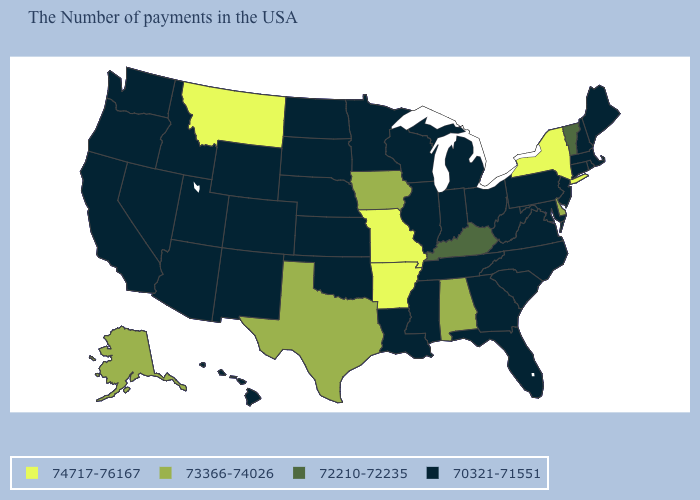What is the value of Colorado?
Be succinct. 70321-71551. Name the states that have a value in the range 72210-72235?
Give a very brief answer. Vermont, Kentucky. What is the value of West Virginia?
Write a very short answer. 70321-71551. Which states have the highest value in the USA?
Write a very short answer. New York, Missouri, Arkansas, Montana. Name the states that have a value in the range 73366-74026?
Quick response, please. Delaware, Alabama, Iowa, Texas, Alaska. Does Indiana have the highest value in the USA?
Answer briefly. No. What is the value of Oregon?
Quick response, please. 70321-71551. Name the states that have a value in the range 72210-72235?
Answer briefly. Vermont, Kentucky. Does Ohio have a lower value than Indiana?
Write a very short answer. No. What is the lowest value in the West?
Short answer required. 70321-71551. Does Utah have the same value as Oklahoma?
Concise answer only. Yes. Which states have the lowest value in the USA?
Concise answer only. Maine, Massachusetts, Rhode Island, New Hampshire, Connecticut, New Jersey, Maryland, Pennsylvania, Virginia, North Carolina, South Carolina, West Virginia, Ohio, Florida, Georgia, Michigan, Indiana, Tennessee, Wisconsin, Illinois, Mississippi, Louisiana, Minnesota, Kansas, Nebraska, Oklahoma, South Dakota, North Dakota, Wyoming, Colorado, New Mexico, Utah, Arizona, Idaho, Nevada, California, Washington, Oregon, Hawaii. Does Kansas have the lowest value in the USA?
Answer briefly. Yes. Among the states that border Kansas , does Missouri have the highest value?
Quick response, please. Yes. Among the states that border Kentucky , does Missouri have the lowest value?
Quick response, please. No. 